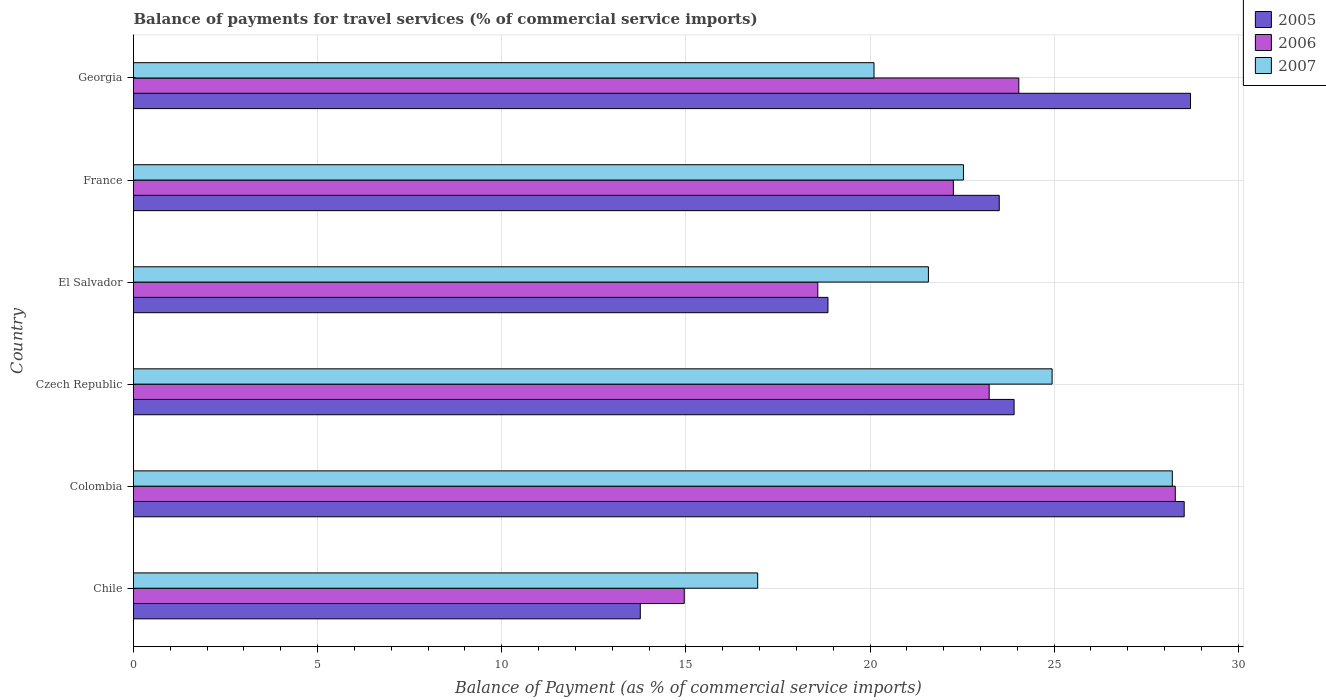How many different coloured bars are there?
Make the answer very short. 3. Are the number of bars per tick equal to the number of legend labels?
Offer a very short reply. Yes. How many bars are there on the 1st tick from the bottom?
Offer a terse response. 3. In how many cases, is the number of bars for a given country not equal to the number of legend labels?
Offer a very short reply. 0. What is the balance of payments for travel services in 2006 in El Salvador?
Provide a succinct answer. 18.58. Across all countries, what is the maximum balance of payments for travel services in 2007?
Your answer should be very brief. 28.21. Across all countries, what is the minimum balance of payments for travel services in 2005?
Offer a terse response. 13.76. What is the total balance of payments for travel services in 2005 in the graph?
Your answer should be compact. 137.27. What is the difference between the balance of payments for travel services in 2005 in Chile and that in Czech Republic?
Make the answer very short. -10.15. What is the difference between the balance of payments for travel services in 2005 in Chile and the balance of payments for travel services in 2007 in Colombia?
Offer a very short reply. -14.45. What is the average balance of payments for travel services in 2007 per country?
Offer a terse response. 22.39. What is the difference between the balance of payments for travel services in 2006 and balance of payments for travel services in 2007 in Czech Republic?
Keep it short and to the point. -1.71. In how many countries, is the balance of payments for travel services in 2007 greater than 18 %?
Keep it short and to the point. 5. What is the ratio of the balance of payments for travel services in 2005 in Chile to that in France?
Provide a succinct answer. 0.59. Is the balance of payments for travel services in 2007 in El Salvador less than that in Georgia?
Ensure brevity in your answer.  No. Is the difference between the balance of payments for travel services in 2006 in Chile and Colombia greater than the difference between the balance of payments for travel services in 2007 in Chile and Colombia?
Keep it short and to the point. No. What is the difference between the highest and the second highest balance of payments for travel services in 2005?
Your answer should be compact. 0.17. What is the difference between the highest and the lowest balance of payments for travel services in 2005?
Make the answer very short. 14.94. In how many countries, is the balance of payments for travel services in 2007 greater than the average balance of payments for travel services in 2007 taken over all countries?
Your answer should be compact. 3. Is the sum of the balance of payments for travel services in 2007 in Chile and El Salvador greater than the maximum balance of payments for travel services in 2006 across all countries?
Ensure brevity in your answer.  Yes. What does the 1st bar from the top in Chile represents?
Give a very brief answer. 2007. Is it the case that in every country, the sum of the balance of payments for travel services in 2005 and balance of payments for travel services in 2006 is greater than the balance of payments for travel services in 2007?
Your answer should be very brief. Yes. How many bars are there?
Your answer should be very brief. 18. What is the difference between two consecutive major ticks on the X-axis?
Provide a short and direct response. 5. Are the values on the major ticks of X-axis written in scientific E-notation?
Keep it short and to the point. No. Does the graph contain grids?
Provide a succinct answer. Yes. How many legend labels are there?
Your answer should be compact. 3. What is the title of the graph?
Offer a very short reply. Balance of payments for travel services (% of commercial service imports). What is the label or title of the X-axis?
Offer a terse response. Balance of Payment (as % of commercial service imports). What is the Balance of Payment (as % of commercial service imports) of 2005 in Chile?
Offer a terse response. 13.76. What is the Balance of Payment (as % of commercial service imports) in 2006 in Chile?
Offer a terse response. 14.96. What is the Balance of Payment (as % of commercial service imports) of 2007 in Chile?
Provide a short and direct response. 16.95. What is the Balance of Payment (as % of commercial service imports) of 2005 in Colombia?
Your answer should be very brief. 28.53. What is the Balance of Payment (as % of commercial service imports) in 2006 in Colombia?
Provide a succinct answer. 28.29. What is the Balance of Payment (as % of commercial service imports) of 2007 in Colombia?
Offer a very short reply. 28.21. What is the Balance of Payment (as % of commercial service imports) of 2005 in Czech Republic?
Offer a terse response. 23.91. What is the Balance of Payment (as % of commercial service imports) of 2006 in Czech Republic?
Your response must be concise. 23.24. What is the Balance of Payment (as % of commercial service imports) of 2007 in Czech Republic?
Your response must be concise. 24.94. What is the Balance of Payment (as % of commercial service imports) of 2005 in El Salvador?
Give a very brief answer. 18.86. What is the Balance of Payment (as % of commercial service imports) in 2006 in El Salvador?
Provide a short and direct response. 18.58. What is the Balance of Payment (as % of commercial service imports) of 2007 in El Salvador?
Your answer should be compact. 21.59. What is the Balance of Payment (as % of commercial service imports) of 2005 in France?
Ensure brevity in your answer.  23.51. What is the Balance of Payment (as % of commercial service imports) in 2006 in France?
Offer a terse response. 22.26. What is the Balance of Payment (as % of commercial service imports) of 2007 in France?
Your response must be concise. 22.54. What is the Balance of Payment (as % of commercial service imports) in 2005 in Georgia?
Your answer should be very brief. 28.7. What is the Balance of Payment (as % of commercial service imports) of 2006 in Georgia?
Your response must be concise. 24.04. What is the Balance of Payment (as % of commercial service imports) in 2007 in Georgia?
Give a very brief answer. 20.11. Across all countries, what is the maximum Balance of Payment (as % of commercial service imports) of 2005?
Keep it short and to the point. 28.7. Across all countries, what is the maximum Balance of Payment (as % of commercial service imports) in 2006?
Give a very brief answer. 28.29. Across all countries, what is the maximum Balance of Payment (as % of commercial service imports) of 2007?
Make the answer very short. 28.21. Across all countries, what is the minimum Balance of Payment (as % of commercial service imports) of 2005?
Ensure brevity in your answer.  13.76. Across all countries, what is the minimum Balance of Payment (as % of commercial service imports) in 2006?
Provide a short and direct response. 14.96. Across all countries, what is the minimum Balance of Payment (as % of commercial service imports) in 2007?
Make the answer very short. 16.95. What is the total Balance of Payment (as % of commercial service imports) of 2005 in the graph?
Offer a very short reply. 137.27. What is the total Balance of Payment (as % of commercial service imports) of 2006 in the graph?
Your response must be concise. 131.36. What is the total Balance of Payment (as % of commercial service imports) in 2007 in the graph?
Make the answer very short. 134.33. What is the difference between the Balance of Payment (as % of commercial service imports) of 2005 in Chile and that in Colombia?
Your response must be concise. -14.77. What is the difference between the Balance of Payment (as % of commercial service imports) in 2006 in Chile and that in Colombia?
Your answer should be very brief. -13.33. What is the difference between the Balance of Payment (as % of commercial service imports) of 2007 in Chile and that in Colombia?
Provide a succinct answer. -11.26. What is the difference between the Balance of Payment (as % of commercial service imports) in 2005 in Chile and that in Czech Republic?
Your answer should be compact. -10.15. What is the difference between the Balance of Payment (as % of commercial service imports) of 2006 in Chile and that in Czech Republic?
Give a very brief answer. -8.28. What is the difference between the Balance of Payment (as % of commercial service imports) of 2007 in Chile and that in Czech Republic?
Keep it short and to the point. -7.99. What is the difference between the Balance of Payment (as % of commercial service imports) of 2005 in Chile and that in El Salvador?
Give a very brief answer. -5.1. What is the difference between the Balance of Payment (as % of commercial service imports) in 2006 in Chile and that in El Salvador?
Provide a succinct answer. -3.63. What is the difference between the Balance of Payment (as % of commercial service imports) in 2007 in Chile and that in El Salvador?
Provide a succinct answer. -4.64. What is the difference between the Balance of Payment (as % of commercial service imports) in 2005 in Chile and that in France?
Provide a succinct answer. -9.75. What is the difference between the Balance of Payment (as % of commercial service imports) in 2006 in Chile and that in France?
Make the answer very short. -7.31. What is the difference between the Balance of Payment (as % of commercial service imports) in 2007 in Chile and that in France?
Give a very brief answer. -5.59. What is the difference between the Balance of Payment (as % of commercial service imports) of 2005 in Chile and that in Georgia?
Give a very brief answer. -14.94. What is the difference between the Balance of Payment (as % of commercial service imports) of 2006 in Chile and that in Georgia?
Your answer should be very brief. -9.08. What is the difference between the Balance of Payment (as % of commercial service imports) in 2007 in Chile and that in Georgia?
Your response must be concise. -3.16. What is the difference between the Balance of Payment (as % of commercial service imports) in 2005 in Colombia and that in Czech Republic?
Your answer should be very brief. 4.62. What is the difference between the Balance of Payment (as % of commercial service imports) of 2006 in Colombia and that in Czech Republic?
Your answer should be very brief. 5.05. What is the difference between the Balance of Payment (as % of commercial service imports) of 2007 in Colombia and that in Czech Republic?
Your answer should be very brief. 3.26. What is the difference between the Balance of Payment (as % of commercial service imports) of 2005 in Colombia and that in El Salvador?
Your response must be concise. 9.67. What is the difference between the Balance of Payment (as % of commercial service imports) in 2006 in Colombia and that in El Salvador?
Offer a very short reply. 9.71. What is the difference between the Balance of Payment (as % of commercial service imports) of 2007 in Colombia and that in El Salvador?
Provide a succinct answer. 6.62. What is the difference between the Balance of Payment (as % of commercial service imports) of 2005 in Colombia and that in France?
Offer a terse response. 5.02. What is the difference between the Balance of Payment (as % of commercial service imports) in 2006 in Colombia and that in France?
Ensure brevity in your answer.  6.03. What is the difference between the Balance of Payment (as % of commercial service imports) in 2007 in Colombia and that in France?
Your answer should be compact. 5.67. What is the difference between the Balance of Payment (as % of commercial service imports) of 2005 in Colombia and that in Georgia?
Give a very brief answer. -0.17. What is the difference between the Balance of Payment (as % of commercial service imports) of 2006 in Colombia and that in Georgia?
Your response must be concise. 4.25. What is the difference between the Balance of Payment (as % of commercial service imports) of 2007 in Colombia and that in Georgia?
Provide a succinct answer. 8.1. What is the difference between the Balance of Payment (as % of commercial service imports) of 2005 in Czech Republic and that in El Salvador?
Ensure brevity in your answer.  5.05. What is the difference between the Balance of Payment (as % of commercial service imports) of 2006 in Czech Republic and that in El Salvador?
Provide a succinct answer. 4.65. What is the difference between the Balance of Payment (as % of commercial service imports) in 2007 in Czech Republic and that in El Salvador?
Keep it short and to the point. 3.36. What is the difference between the Balance of Payment (as % of commercial service imports) in 2005 in Czech Republic and that in France?
Offer a terse response. 0.4. What is the difference between the Balance of Payment (as % of commercial service imports) in 2006 in Czech Republic and that in France?
Ensure brevity in your answer.  0.97. What is the difference between the Balance of Payment (as % of commercial service imports) of 2007 in Czech Republic and that in France?
Give a very brief answer. 2.41. What is the difference between the Balance of Payment (as % of commercial service imports) of 2005 in Czech Republic and that in Georgia?
Ensure brevity in your answer.  -4.79. What is the difference between the Balance of Payment (as % of commercial service imports) in 2006 in Czech Republic and that in Georgia?
Provide a succinct answer. -0.8. What is the difference between the Balance of Payment (as % of commercial service imports) of 2007 in Czech Republic and that in Georgia?
Make the answer very short. 4.84. What is the difference between the Balance of Payment (as % of commercial service imports) of 2005 in El Salvador and that in France?
Your answer should be very brief. -4.65. What is the difference between the Balance of Payment (as % of commercial service imports) in 2006 in El Salvador and that in France?
Make the answer very short. -3.68. What is the difference between the Balance of Payment (as % of commercial service imports) in 2007 in El Salvador and that in France?
Ensure brevity in your answer.  -0.95. What is the difference between the Balance of Payment (as % of commercial service imports) of 2005 in El Salvador and that in Georgia?
Offer a very short reply. -9.85. What is the difference between the Balance of Payment (as % of commercial service imports) in 2006 in El Salvador and that in Georgia?
Provide a short and direct response. -5.46. What is the difference between the Balance of Payment (as % of commercial service imports) in 2007 in El Salvador and that in Georgia?
Keep it short and to the point. 1.48. What is the difference between the Balance of Payment (as % of commercial service imports) of 2005 in France and that in Georgia?
Your answer should be very brief. -5.19. What is the difference between the Balance of Payment (as % of commercial service imports) of 2006 in France and that in Georgia?
Keep it short and to the point. -1.78. What is the difference between the Balance of Payment (as % of commercial service imports) in 2007 in France and that in Georgia?
Offer a terse response. 2.43. What is the difference between the Balance of Payment (as % of commercial service imports) of 2005 in Chile and the Balance of Payment (as % of commercial service imports) of 2006 in Colombia?
Your answer should be compact. -14.53. What is the difference between the Balance of Payment (as % of commercial service imports) in 2005 in Chile and the Balance of Payment (as % of commercial service imports) in 2007 in Colombia?
Make the answer very short. -14.45. What is the difference between the Balance of Payment (as % of commercial service imports) in 2006 in Chile and the Balance of Payment (as % of commercial service imports) in 2007 in Colombia?
Provide a succinct answer. -13.25. What is the difference between the Balance of Payment (as % of commercial service imports) of 2005 in Chile and the Balance of Payment (as % of commercial service imports) of 2006 in Czech Republic?
Keep it short and to the point. -9.47. What is the difference between the Balance of Payment (as % of commercial service imports) in 2005 in Chile and the Balance of Payment (as % of commercial service imports) in 2007 in Czech Republic?
Your response must be concise. -11.18. What is the difference between the Balance of Payment (as % of commercial service imports) in 2006 in Chile and the Balance of Payment (as % of commercial service imports) in 2007 in Czech Republic?
Offer a very short reply. -9.99. What is the difference between the Balance of Payment (as % of commercial service imports) in 2005 in Chile and the Balance of Payment (as % of commercial service imports) in 2006 in El Salvador?
Your answer should be very brief. -4.82. What is the difference between the Balance of Payment (as % of commercial service imports) in 2005 in Chile and the Balance of Payment (as % of commercial service imports) in 2007 in El Salvador?
Offer a very short reply. -7.82. What is the difference between the Balance of Payment (as % of commercial service imports) in 2006 in Chile and the Balance of Payment (as % of commercial service imports) in 2007 in El Salvador?
Offer a terse response. -6.63. What is the difference between the Balance of Payment (as % of commercial service imports) in 2005 in Chile and the Balance of Payment (as % of commercial service imports) in 2006 in France?
Make the answer very short. -8.5. What is the difference between the Balance of Payment (as % of commercial service imports) of 2005 in Chile and the Balance of Payment (as % of commercial service imports) of 2007 in France?
Your response must be concise. -8.78. What is the difference between the Balance of Payment (as % of commercial service imports) in 2006 in Chile and the Balance of Payment (as % of commercial service imports) in 2007 in France?
Provide a succinct answer. -7.58. What is the difference between the Balance of Payment (as % of commercial service imports) of 2005 in Chile and the Balance of Payment (as % of commercial service imports) of 2006 in Georgia?
Provide a short and direct response. -10.28. What is the difference between the Balance of Payment (as % of commercial service imports) in 2005 in Chile and the Balance of Payment (as % of commercial service imports) in 2007 in Georgia?
Offer a very short reply. -6.35. What is the difference between the Balance of Payment (as % of commercial service imports) in 2006 in Chile and the Balance of Payment (as % of commercial service imports) in 2007 in Georgia?
Your answer should be very brief. -5.15. What is the difference between the Balance of Payment (as % of commercial service imports) of 2005 in Colombia and the Balance of Payment (as % of commercial service imports) of 2006 in Czech Republic?
Ensure brevity in your answer.  5.3. What is the difference between the Balance of Payment (as % of commercial service imports) of 2005 in Colombia and the Balance of Payment (as % of commercial service imports) of 2007 in Czech Republic?
Your answer should be compact. 3.59. What is the difference between the Balance of Payment (as % of commercial service imports) in 2006 in Colombia and the Balance of Payment (as % of commercial service imports) in 2007 in Czech Republic?
Offer a terse response. 3.34. What is the difference between the Balance of Payment (as % of commercial service imports) in 2005 in Colombia and the Balance of Payment (as % of commercial service imports) in 2006 in El Salvador?
Make the answer very short. 9.95. What is the difference between the Balance of Payment (as % of commercial service imports) of 2005 in Colombia and the Balance of Payment (as % of commercial service imports) of 2007 in El Salvador?
Your answer should be compact. 6.95. What is the difference between the Balance of Payment (as % of commercial service imports) in 2006 in Colombia and the Balance of Payment (as % of commercial service imports) in 2007 in El Salvador?
Your response must be concise. 6.7. What is the difference between the Balance of Payment (as % of commercial service imports) in 2005 in Colombia and the Balance of Payment (as % of commercial service imports) in 2006 in France?
Your answer should be compact. 6.27. What is the difference between the Balance of Payment (as % of commercial service imports) in 2005 in Colombia and the Balance of Payment (as % of commercial service imports) in 2007 in France?
Give a very brief answer. 5.99. What is the difference between the Balance of Payment (as % of commercial service imports) in 2006 in Colombia and the Balance of Payment (as % of commercial service imports) in 2007 in France?
Your answer should be very brief. 5.75. What is the difference between the Balance of Payment (as % of commercial service imports) of 2005 in Colombia and the Balance of Payment (as % of commercial service imports) of 2006 in Georgia?
Your answer should be very brief. 4.49. What is the difference between the Balance of Payment (as % of commercial service imports) of 2005 in Colombia and the Balance of Payment (as % of commercial service imports) of 2007 in Georgia?
Provide a short and direct response. 8.42. What is the difference between the Balance of Payment (as % of commercial service imports) of 2006 in Colombia and the Balance of Payment (as % of commercial service imports) of 2007 in Georgia?
Offer a terse response. 8.18. What is the difference between the Balance of Payment (as % of commercial service imports) of 2005 in Czech Republic and the Balance of Payment (as % of commercial service imports) of 2006 in El Salvador?
Give a very brief answer. 5.33. What is the difference between the Balance of Payment (as % of commercial service imports) of 2005 in Czech Republic and the Balance of Payment (as % of commercial service imports) of 2007 in El Salvador?
Offer a terse response. 2.33. What is the difference between the Balance of Payment (as % of commercial service imports) in 2006 in Czech Republic and the Balance of Payment (as % of commercial service imports) in 2007 in El Salvador?
Your response must be concise. 1.65. What is the difference between the Balance of Payment (as % of commercial service imports) in 2005 in Czech Republic and the Balance of Payment (as % of commercial service imports) in 2006 in France?
Offer a terse response. 1.65. What is the difference between the Balance of Payment (as % of commercial service imports) in 2005 in Czech Republic and the Balance of Payment (as % of commercial service imports) in 2007 in France?
Make the answer very short. 1.37. What is the difference between the Balance of Payment (as % of commercial service imports) of 2006 in Czech Republic and the Balance of Payment (as % of commercial service imports) of 2007 in France?
Your response must be concise. 0.7. What is the difference between the Balance of Payment (as % of commercial service imports) of 2005 in Czech Republic and the Balance of Payment (as % of commercial service imports) of 2006 in Georgia?
Your response must be concise. -0.13. What is the difference between the Balance of Payment (as % of commercial service imports) of 2005 in Czech Republic and the Balance of Payment (as % of commercial service imports) of 2007 in Georgia?
Keep it short and to the point. 3.8. What is the difference between the Balance of Payment (as % of commercial service imports) of 2006 in Czech Republic and the Balance of Payment (as % of commercial service imports) of 2007 in Georgia?
Offer a very short reply. 3.13. What is the difference between the Balance of Payment (as % of commercial service imports) of 2005 in El Salvador and the Balance of Payment (as % of commercial service imports) of 2006 in France?
Provide a succinct answer. -3.41. What is the difference between the Balance of Payment (as % of commercial service imports) of 2005 in El Salvador and the Balance of Payment (as % of commercial service imports) of 2007 in France?
Your answer should be very brief. -3.68. What is the difference between the Balance of Payment (as % of commercial service imports) of 2006 in El Salvador and the Balance of Payment (as % of commercial service imports) of 2007 in France?
Keep it short and to the point. -3.96. What is the difference between the Balance of Payment (as % of commercial service imports) in 2005 in El Salvador and the Balance of Payment (as % of commercial service imports) in 2006 in Georgia?
Your response must be concise. -5.18. What is the difference between the Balance of Payment (as % of commercial service imports) of 2005 in El Salvador and the Balance of Payment (as % of commercial service imports) of 2007 in Georgia?
Provide a succinct answer. -1.25. What is the difference between the Balance of Payment (as % of commercial service imports) in 2006 in El Salvador and the Balance of Payment (as % of commercial service imports) in 2007 in Georgia?
Give a very brief answer. -1.53. What is the difference between the Balance of Payment (as % of commercial service imports) in 2005 in France and the Balance of Payment (as % of commercial service imports) in 2006 in Georgia?
Your answer should be very brief. -0.53. What is the difference between the Balance of Payment (as % of commercial service imports) of 2005 in France and the Balance of Payment (as % of commercial service imports) of 2007 in Georgia?
Keep it short and to the point. 3.4. What is the difference between the Balance of Payment (as % of commercial service imports) in 2006 in France and the Balance of Payment (as % of commercial service imports) in 2007 in Georgia?
Provide a succinct answer. 2.15. What is the average Balance of Payment (as % of commercial service imports) in 2005 per country?
Offer a terse response. 22.88. What is the average Balance of Payment (as % of commercial service imports) in 2006 per country?
Give a very brief answer. 21.89. What is the average Balance of Payment (as % of commercial service imports) in 2007 per country?
Your answer should be compact. 22.39. What is the difference between the Balance of Payment (as % of commercial service imports) of 2005 and Balance of Payment (as % of commercial service imports) of 2006 in Chile?
Offer a terse response. -1.19. What is the difference between the Balance of Payment (as % of commercial service imports) of 2005 and Balance of Payment (as % of commercial service imports) of 2007 in Chile?
Provide a succinct answer. -3.19. What is the difference between the Balance of Payment (as % of commercial service imports) in 2006 and Balance of Payment (as % of commercial service imports) in 2007 in Chile?
Make the answer very short. -1.99. What is the difference between the Balance of Payment (as % of commercial service imports) of 2005 and Balance of Payment (as % of commercial service imports) of 2006 in Colombia?
Ensure brevity in your answer.  0.24. What is the difference between the Balance of Payment (as % of commercial service imports) of 2005 and Balance of Payment (as % of commercial service imports) of 2007 in Colombia?
Keep it short and to the point. 0.32. What is the difference between the Balance of Payment (as % of commercial service imports) in 2006 and Balance of Payment (as % of commercial service imports) in 2007 in Colombia?
Provide a succinct answer. 0.08. What is the difference between the Balance of Payment (as % of commercial service imports) in 2005 and Balance of Payment (as % of commercial service imports) in 2006 in Czech Republic?
Ensure brevity in your answer.  0.68. What is the difference between the Balance of Payment (as % of commercial service imports) in 2005 and Balance of Payment (as % of commercial service imports) in 2007 in Czech Republic?
Your answer should be very brief. -1.03. What is the difference between the Balance of Payment (as % of commercial service imports) of 2006 and Balance of Payment (as % of commercial service imports) of 2007 in Czech Republic?
Your answer should be compact. -1.71. What is the difference between the Balance of Payment (as % of commercial service imports) in 2005 and Balance of Payment (as % of commercial service imports) in 2006 in El Salvador?
Provide a short and direct response. 0.28. What is the difference between the Balance of Payment (as % of commercial service imports) of 2005 and Balance of Payment (as % of commercial service imports) of 2007 in El Salvador?
Offer a very short reply. -2.73. What is the difference between the Balance of Payment (as % of commercial service imports) of 2006 and Balance of Payment (as % of commercial service imports) of 2007 in El Salvador?
Ensure brevity in your answer.  -3. What is the difference between the Balance of Payment (as % of commercial service imports) in 2005 and Balance of Payment (as % of commercial service imports) in 2006 in France?
Provide a short and direct response. 1.25. What is the difference between the Balance of Payment (as % of commercial service imports) of 2005 and Balance of Payment (as % of commercial service imports) of 2007 in France?
Provide a short and direct response. 0.97. What is the difference between the Balance of Payment (as % of commercial service imports) in 2006 and Balance of Payment (as % of commercial service imports) in 2007 in France?
Ensure brevity in your answer.  -0.27. What is the difference between the Balance of Payment (as % of commercial service imports) in 2005 and Balance of Payment (as % of commercial service imports) in 2006 in Georgia?
Offer a very short reply. 4.66. What is the difference between the Balance of Payment (as % of commercial service imports) of 2005 and Balance of Payment (as % of commercial service imports) of 2007 in Georgia?
Give a very brief answer. 8.59. What is the difference between the Balance of Payment (as % of commercial service imports) of 2006 and Balance of Payment (as % of commercial service imports) of 2007 in Georgia?
Provide a succinct answer. 3.93. What is the ratio of the Balance of Payment (as % of commercial service imports) of 2005 in Chile to that in Colombia?
Offer a very short reply. 0.48. What is the ratio of the Balance of Payment (as % of commercial service imports) of 2006 in Chile to that in Colombia?
Make the answer very short. 0.53. What is the ratio of the Balance of Payment (as % of commercial service imports) in 2007 in Chile to that in Colombia?
Your answer should be compact. 0.6. What is the ratio of the Balance of Payment (as % of commercial service imports) of 2005 in Chile to that in Czech Republic?
Your answer should be compact. 0.58. What is the ratio of the Balance of Payment (as % of commercial service imports) of 2006 in Chile to that in Czech Republic?
Give a very brief answer. 0.64. What is the ratio of the Balance of Payment (as % of commercial service imports) of 2007 in Chile to that in Czech Republic?
Provide a succinct answer. 0.68. What is the ratio of the Balance of Payment (as % of commercial service imports) of 2005 in Chile to that in El Salvador?
Provide a short and direct response. 0.73. What is the ratio of the Balance of Payment (as % of commercial service imports) in 2006 in Chile to that in El Salvador?
Provide a succinct answer. 0.8. What is the ratio of the Balance of Payment (as % of commercial service imports) of 2007 in Chile to that in El Salvador?
Offer a very short reply. 0.79. What is the ratio of the Balance of Payment (as % of commercial service imports) of 2005 in Chile to that in France?
Ensure brevity in your answer.  0.59. What is the ratio of the Balance of Payment (as % of commercial service imports) in 2006 in Chile to that in France?
Make the answer very short. 0.67. What is the ratio of the Balance of Payment (as % of commercial service imports) in 2007 in Chile to that in France?
Offer a terse response. 0.75. What is the ratio of the Balance of Payment (as % of commercial service imports) of 2005 in Chile to that in Georgia?
Your answer should be very brief. 0.48. What is the ratio of the Balance of Payment (as % of commercial service imports) of 2006 in Chile to that in Georgia?
Provide a short and direct response. 0.62. What is the ratio of the Balance of Payment (as % of commercial service imports) of 2007 in Chile to that in Georgia?
Provide a short and direct response. 0.84. What is the ratio of the Balance of Payment (as % of commercial service imports) of 2005 in Colombia to that in Czech Republic?
Offer a very short reply. 1.19. What is the ratio of the Balance of Payment (as % of commercial service imports) of 2006 in Colombia to that in Czech Republic?
Offer a terse response. 1.22. What is the ratio of the Balance of Payment (as % of commercial service imports) in 2007 in Colombia to that in Czech Republic?
Keep it short and to the point. 1.13. What is the ratio of the Balance of Payment (as % of commercial service imports) of 2005 in Colombia to that in El Salvador?
Offer a very short reply. 1.51. What is the ratio of the Balance of Payment (as % of commercial service imports) of 2006 in Colombia to that in El Salvador?
Your answer should be very brief. 1.52. What is the ratio of the Balance of Payment (as % of commercial service imports) in 2007 in Colombia to that in El Salvador?
Keep it short and to the point. 1.31. What is the ratio of the Balance of Payment (as % of commercial service imports) of 2005 in Colombia to that in France?
Make the answer very short. 1.21. What is the ratio of the Balance of Payment (as % of commercial service imports) of 2006 in Colombia to that in France?
Provide a short and direct response. 1.27. What is the ratio of the Balance of Payment (as % of commercial service imports) of 2007 in Colombia to that in France?
Ensure brevity in your answer.  1.25. What is the ratio of the Balance of Payment (as % of commercial service imports) in 2005 in Colombia to that in Georgia?
Offer a very short reply. 0.99. What is the ratio of the Balance of Payment (as % of commercial service imports) in 2006 in Colombia to that in Georgia?
Offer a very short reply. 1.18. What is the ratio of the Balance of Payment (as % of commercial service imports) of 2007 in Colombia to that in Georgia?
Your response must be concise. 1.4. What is the ratio of the Balance of Payment (as % of commercial service imports) in 2005 in Czech Republic to that in El Salvador?
Your answer should be compact. 1.27. What is the ratio of the Balance of Payment (as % of commercial service imports) of 2006 in Czech Republic to that in El Salvador?
Offer a terse response. 1.25. What is the ratio of the Balance of Payment (as % of commercial service imports) in 2007 in Czech Republic to that in El Salvador?
Offer a terse response. 1.16. What is the ratio of the Balance of Payment (as % of commercial service imports) in 2005 in Czech Republic to that in France?
Your response must be concise. 1.02. What is the ratio of the Balance of Payment (as % of commercial service imports) of 2006 in Czech Republic to that in France?
Give a very brief answer. 1.04. What is the ratio of the Balance of Payment (as % of commercial service imports) of 2007 in Czech Republic to that in France?
Provide a succinct answer. 1.11. What is the ratio of the Balance of Payment (as % of commercial service imports) of 2005 in Czech Republic to that in Georgia?
Offer a terse response. 0.83. What is the ratio of the Balance of Payment (as % of commercial service imports) of 2006 in Czech Republic to that in Georgia?
Give a very brief answer. 0.97. What is the ratio of the Balance of Payment (as % of commercial service imports) of 2007 in Czech Republic to that in Georgia?
Your answer should be very brief. 1.24. What is the ratio of the Balance of Payment (as % of commercial service imports) of 2005 in El Salvador to that in France?
Provide a succinct answer. 0.8. What is the ratio of the Balance of Payment (as % of commercial service imports) of 2006 in El Salvador to that in France?
Your answer should be compact. 0.83. What is the ratio of the Balance of Payment (as % of commercial service imports) of 2007 in El Salvador to that in France?
Provide a short and direct response. 0.96. What is the ratio of the Balance of Payment (as % of commercial service imports) of 2005 in El Salvador to that in Georgia?
Keep it short and to the point. 0.66. What is the ratio of the Balance of Payment (as % of commercial service imports) of 2006 in El Salvador to that in Georgia?
Your answer should be very brief. 0.77. What is the ratio of the Balance of Payment (as % of commercial service imports) of 2007 in El Salvador to that in Georgia?
Your answer should be very brief. 1.07. What is the ratio of the Balance of Payment (as % of commercial service imports) in 2005 in France to that in Georgia?
Your answer should be compact. 0.82. What is the ratio of the Balance of Payment (as % of commercial service imports) in 2006 in France to that in Georgia?
Your response must be concise. 0.93. What is the ratio of the Balance of Payment (as % of commercial service imports) in 2007 in France to that in Georgia?
Your answer should be compact. 1.12. What is the difference between the highest and the second highest Balance of Payment (as % of commercial service imports) of 2005?
Your response must be concise. 0.17. What is the difference between the highest and the second highest Balance of Payment (as % of commercial service imports) of 2006?
Make the answer very short. 4.25. What is the difference between the highest and the second highest Balance of Payment (as % of commercial service imports) of 2007?
Your response must be concise. 3.26. What is the difference between the highest and the lowest Balance of Payment (as % of commercial service imports) in 2005?
Your answer should be compact. 14.94. What is the difference between the highest and the lowest Balance of Payment (as % of commercial service imports) in 2006?
Provide a succinct answer. 13.33. What is the difference between the highest and the lowest Balance of Payment (as % of commercial service imports) in 2007?
Your answer should be very brief. 11.26. 